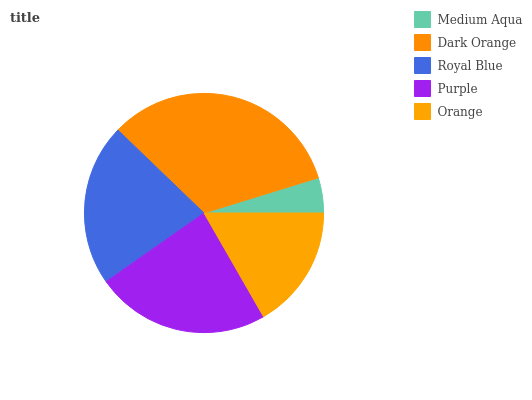Is Medium Aqua the minimum?
Answer yes or no. Yes. Is Dark Orange the maximum?
Answer yes or no. Yes. Is Royal Blue the minimum?
Answer yes or no. No. Is Royal Blue the maximum?
Answer yes or no. No. Is Dark Orange greater than Royal Blue?
Answer yes or no. Yes. Is Royal Blue less than Dark Orange?
Answer yes or no. Yes. Is Royal Blue greater than Dark Orange?
Answer yes or no. No. Is Dark Orange less than Royal Blue?
Answer yes or no. No. Is Royal Blue the high median?
Answer yes or no. Yes. Is Royal Blue the low median?
Answer yes or no. Yes. Is Orange the high median?
Answer yes or no. No. Is Medium Aqua the low median?
Answer yes or no. No. 